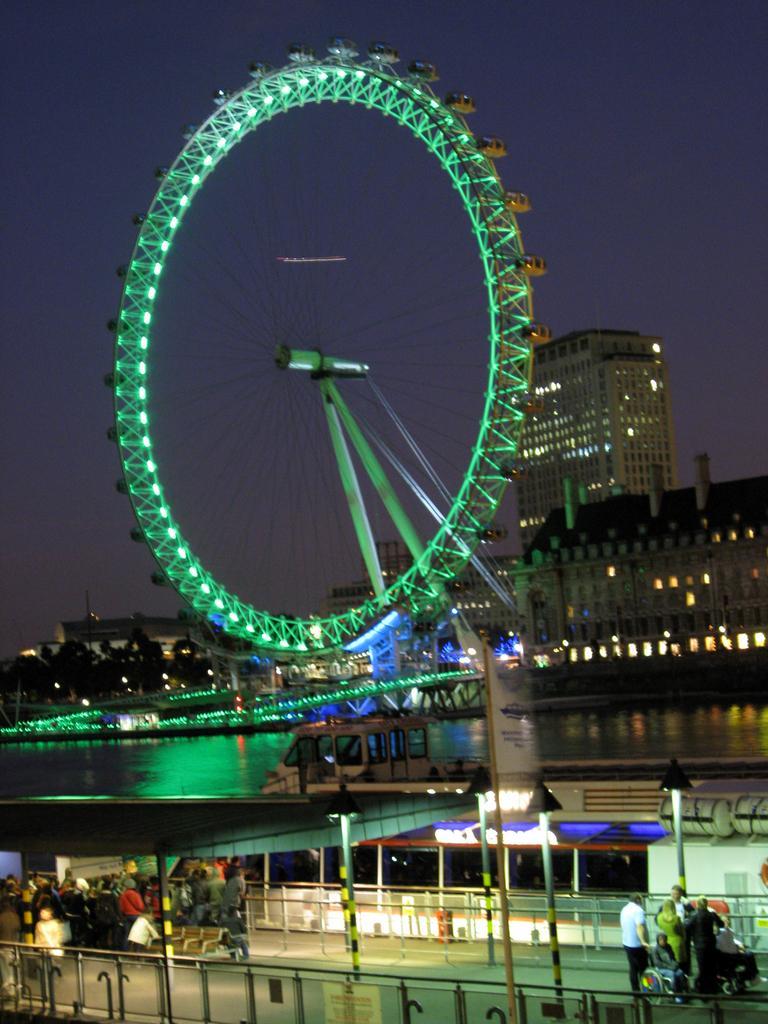Describe this image in one or two sentences. In this picture we can see people on the ground and in the background we can see buildings,sky. 